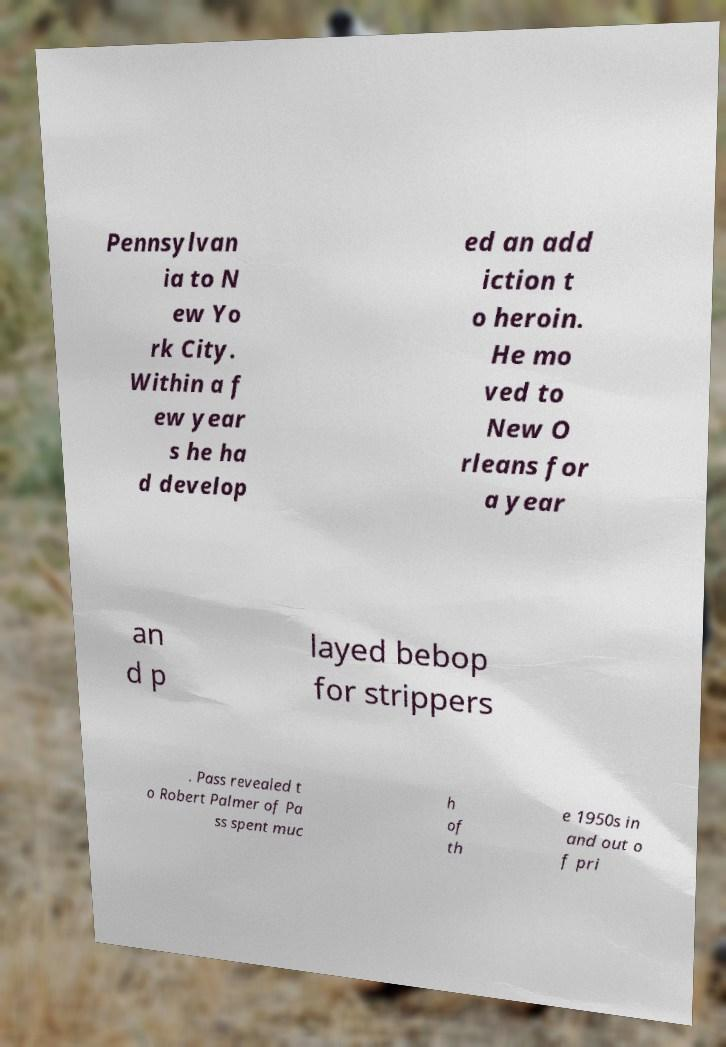For documentation purposes, I need the text within this image transcribed. Could you provide that? Pennsylvan ia to N ew Yo rk City. Within a f ew year s he ha d develop ed an add iction t o heroin. He mo ved to New O rleans for a year an d p layed bebop for strippers . Pass revealed t o Robert Palmer of Pa ss spent muc h of th e 1950s in and out o f pri 